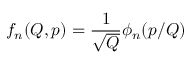<formula> <loc_0><loc_0><loc_500><loc_500>f _ { n } ( Q , p ) = \frac { 1 } { \sqrt { Q } } \phi _ { n } ( p / Q )</formula> 